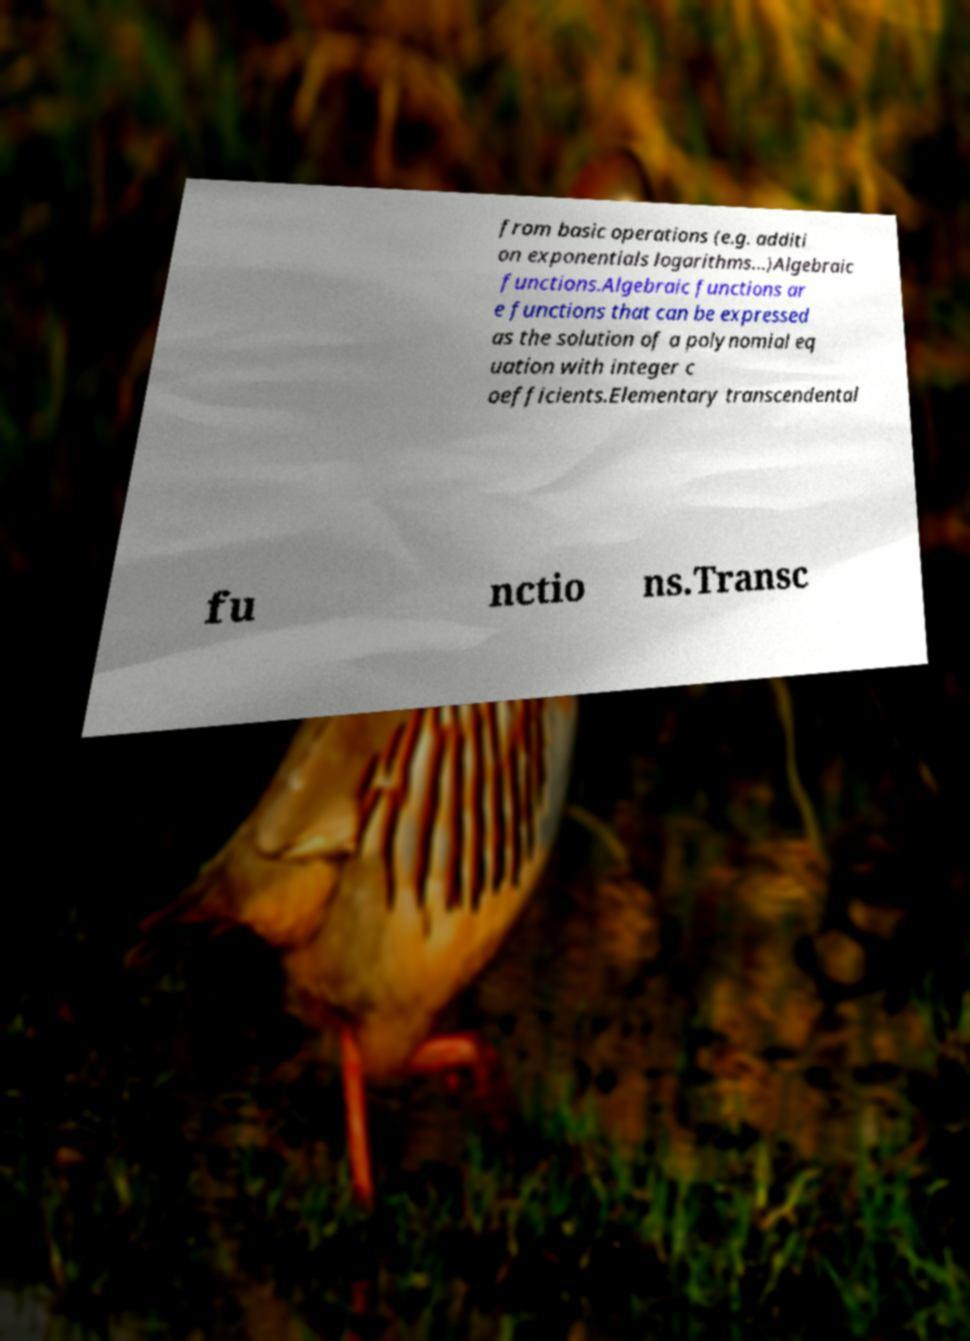Can you accurately transcribe the text from the provided image for me? from basic operations (e.g. additi on exponentials logarithms...)Algebraic functions.Algebraic functions ar e functions that can be expressed as the solution of a polynomial eq uation with integer c oefficients.Elementary transcendental fu nctio ns.Transc 